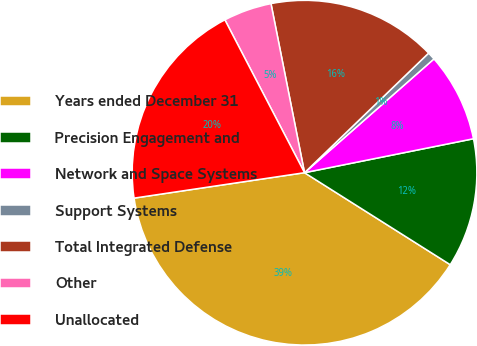<chart> <loc_0><loc_0><loc_500><loc_500><pie_chart><fcel>Years ended December 31<fcel>Precision Engagement and<fcel>Network and Space Systems<fcel>Support Systems<fcel>Total Integrated Defense<fcel>Other<fcel>Unallocated<nl><fcel>38.68%<fcel>12.12%<fcel>8.32%<fcel>0.73%<fcel>15.91%<fcel>4.53%<fcel>19.71%<nl></chart> 